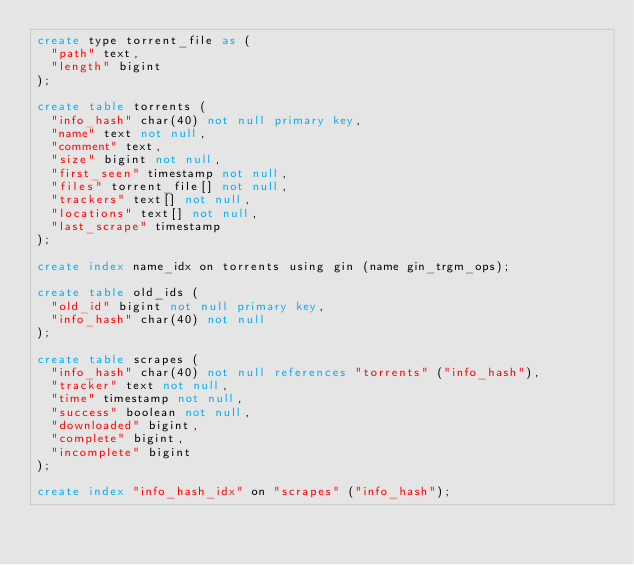<code> <loc_0><loc_0><loc_500><loc_500><_SQL_>create type torrent_file as (
  "path" text,
  "length" bigint
);

create table torrents (
  "info_hash" char(40) not null primary key,
  "name" text not null,
  "comment" text,
  "size" bigint not null,
  "first_seen" timestamp not null,
  "files" torrent_file[] not null,
  "trackers" text[] not null,
  "locations" text[] not null,
  "last_scrape" timestamp
);

create index name_idx on torrents using gin (name gin_trgm_ops);

create table old_ids (
  "old_id" bigint not null primary key,
  "info_hash" char(40) not null
);

create table scrapes (
  "info_hash" char(40) not null references "torrents" ("info_hash"),
  "tracker" text not null,
  "time" timestamp not null,
  "success" boolean not null,
  "downloaded" bigint,
  "complete" bigint,
  "incomplete" bigint
);

create index "info_hash_idx" on "scrapes" ("info_hash");
</code> 